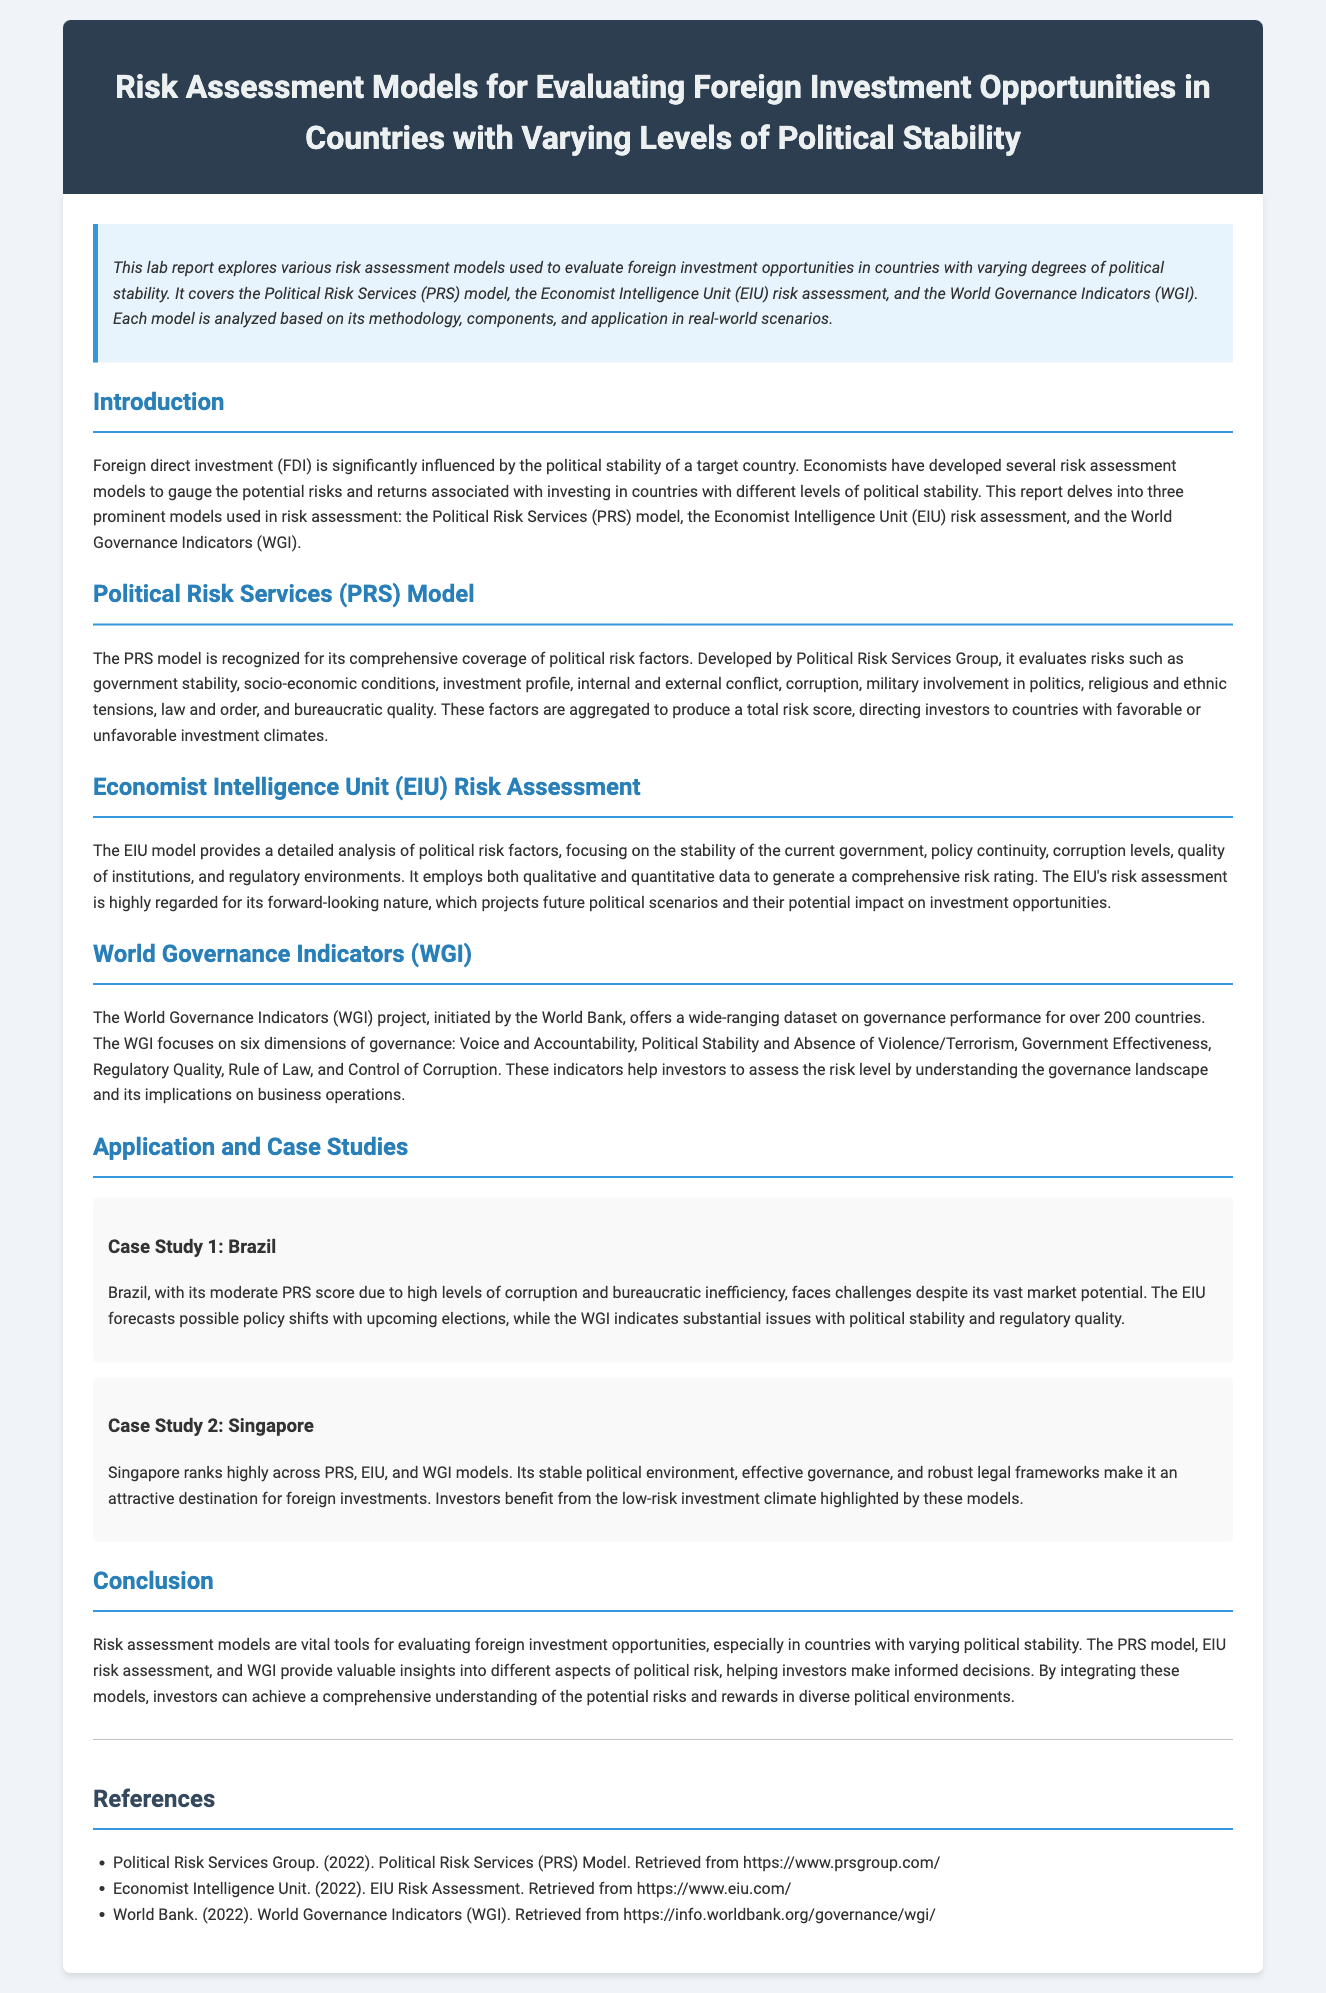What is the focus of the lab report? The focus of the lab report is the exploration of risk assessment models used to evaluate foreign investment opportunities in countries with varying degrees of political stability.
Answer: risk assessment models for evaluating foreign investment opportunities in countries with varying levels of political stability Which model is recognized for its comprehensive coverage of political risk factors? The document states that the Political Risk Services model is recognized for its comprehensive coverage of political risk factors.
Answer: Political Risk Services (PRS) model What are the six dimensions of governance in the World Governance Indicators? The six dimensions of governance can be found in the WGI section, listing Voice and Accountability, Political Stability and Absence of Violence/Terrorism, Government Effectiveness, Regulatory Quality, Rule of Law, and Control of Corruption.
Answer: Voice and Accountability, Political Stability and Absence of Violence/Terrorism, Government Effectiveness, Regulatory Quality, Rule of Law, and Control of Corruption Which country is highlighted as having a low-risk investment climate? The document mentions that Singapore ranks highly across PRS, EIU, and WGI models, indicating a low-risk investment climate.
Answer: Singapore What type of data does the EIU model employ? The EIU model employs both qualitative and quantitative data to generate a comprehensive risk rating.
Answer: qualitative and quantitative data What aspect of Brazil impacts its PRS score according to the document? The document states that Brazil has high levels of corruption and bureaucratic inefficiency, impacting its PRS score.
Answer: high levels of corruption and bureaucratic inefficiency What does the WGI project help investors assess? The WGI project helps investors assess the risk level by understanding the governance landscape and its implications on business operations.
Answer: governance landscape and its implications on business operations How many countries' governance performance is covered by the World Governance Indicators? The WGI project offers a wide-ranging dataset on governance performance for over 200 countries.
Answer: over 200 countries 